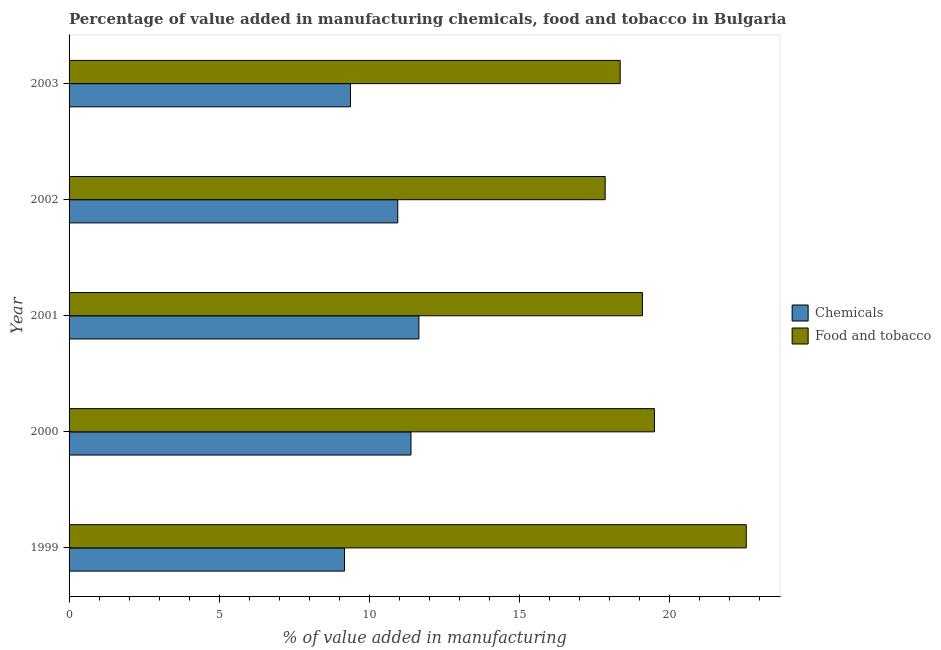Are the number of bars on each tick of the Y-axis equal?
Ensure brevity in your answer.  Yes. How many bars are there on the 3rd tick from the bottom?
Ensure brevity in your answer.  2. What is the value added by  manufacturing chemicals in 2000?
Provide a short and direct response. 11.4. Across all years, what is the maximum value added by  manufacturing chemicals?
Provide a succinct answer. 11.66. Across all years, what is the minimum value added by  manufacturing chemicals?
Your answer should be very brief. 9.18. In which year was the value added by  manufacturing chemicals maximum?
Ensure brevity in your answer.  2001. What is the total value added by manufacturing food and tobacco in the graph?
Provide a short and direct response. 97.43. What is the difference between the value added by  manufacturing chemicals in 2001 and that in 2002?
Your answer should be very brief. 0.7. What is the difference between the value added by  manufacturing chemicals in 2001 and the value added by manufacturing food and tobacco in 2002?
Your answer should be compact. -6.21. What is the average value added by  manufacturing chemicals per year?
Provide a short and direct response. 10.51. In the year 1999, what is the difference between the value added by  manufacturing chemicals and value added by manufacturing food and tobacco?
Provide a short and direct response. -13.39. What is the ratio of the value added by manufacturing food and tobacco in 1999 to that in 2003?
Offer a very short reply. 1.23. Is the value added by  manufacturing chemicals in 1999 less than that in 2003?
Offer a terse response. Yes. What is the difference between the highest and the second highest value added by  manufacturing chemicals?
Offer a terse response. 0.26. In how many years, is the value added by manufacturing food and tobacco greater than the average value added by manufacturing food and tobacco taken over all years?
Make the answer very short. 2. Is the sum of the value added by  manufacturing chemicals in 2000 and 2001 greater than the maximum value added by manufacturing food and tobacco across all years?
Provide a short and direct response. Yes. What does the 2nd bar from the top in 2003 represents?
Ensure brevity in your answer.  Chemicals. What does the 1st bar from the bottom in 1999 represents?
Your response must be concise. Chemicals. How many bars are there?
Your response must be concise. 10. What is the difference between two consecutive major ticks on the X-axis?
Offer a very short reply. 5. Are the values on the major ticks of X-axis written in scientific E-notation?
Provide a short and direct response. No. Does the graph contain grids?
Ensure brevity in your answer.  No. What is the title of the graph?
Ensure brevity in your answer.  Percentage of value added in manufacturing chemicals, food and tobacco in Bulgaria. What is the label or title of the X-axis?
Provide a short and direct response. % of value added in manufacturing. What is the label or title of the Y-axis?
Offer a terse response. Year. What is the % of value added in manufacturing of Chemicals in 1999?
Offer a very short reply. 9.18. What is the % of value added in manufacturing of Food and tobacco in 1999?
Keep it short and to the point. 22.57. What is the % of value added in manufacturing of Chemicals in 2000?
Provide a short and direct response. 11.4. What is the % of value added in manufacturing in Food and tobacco in 2000?
Provide a short and direct response. 19.51. What is the % of value added in manufacturing of Chemicals in 2001?
Your answer should be very brief. 11.66. What is the % of value added in manufacturing in Food and tobacco in 2001?
Make the answer very short. 19.11. What is the % of value added in manufacturing in Chemicals in 2002?
Your answer should be compact. 10.95. What is the % of value added in manufacturing of Food and tobacco in 2002?
Your answer should be very brief. 17.87. What is the % of value added in manufacturing of Chemicals in 2003?
Give a very brief answer. 9.38. What is the % of value added in manufacturing of Food and tobacco in 2003?
Provide a succinct answer. 18.37. Across all years, what is the maximum % of value added in manufacturing in Chemicals?
Ensure brevity in your answer.  11.66. Across all years, what is the maximum % of value added in manufacturing in Food and tobacco?
Provide a succinct answer. 22.57. Across all years, what is the minimum % of value added in manufacturing in Chemicals?
Give a very brief answer. 9.18. Across all years, what is the minimum % of value added in manufacturing in Food and tobacco?
Provide a short and direct response. 17.87. What is the total % of value added in manufacturing in Chemicals in the graph?
Your answer should be compact. 52.57. What is the total % of value added in manufacturing of Food and tobacco in the graph?
Your response must be concise. 97.43. What is the difference between the % of value added in manufacturing in Chemicals in 1999 and that in 2000?
Provide a succinct answer. -2.22. What is the difference between the % of value added in manufacturing in Food and tobacco in 1999 and that in 2000?
Provide a succinct answer. 3.06. What is the difference between the % of value added in manufacturing in Chemicals in 1999 and that in 2001?
Offer a terse response. -2.48. What is the difference between the % of value added in manufacturing of Food and tobacco in 1999 and that in 2001?
Offer a terse response. 3.46. What is the difference between the % of value added in manufacturing in Chemicals in 1999 and that in 2002?
Provide a succinct answer. -1.77. What is the difference between the % of value added in manufacturing in Food and tobacco in 1999 and that in 2002?
Ensure brevity in your answer.  4.7. What is the difference between the % of value added in manufacturing in Chemicals in 1999 and that in 2003?
Your answer should be very brief. -0.2. What is the difference between the % of value added in manufacturing in Food and tobacco in 1999 and that in 2003?
Your answer should be very brief. 4.2. What is the difference between the % of value added in manufacturing in Chemicals in 2000 and that in 2001?
Offer a terse response. -0.26. What is the difference between the % of value added in manufacturing in Food and tobacco in 2000 and that in 2001?
Offer a very short reply. 0.4. What is the difference between the % of value added in manufacturing of Chemicals in 2000 and that in 2002?
Keep it short and to the point. 0.44. What is the difference between the % of value added in manufacturing in Food and tobacco in 2000 and that in 2002?
Ensure brevity in your answer.  1.64. What is the difference between the % of value added in manufacturing of Chemicals in 2000 and that in 2003?
Give a very brief answer. 2.02. What is the difference between the % of value added in manufacturing in Food and tobacco in 2000 and that in 2003?
Give a very brief answer. 1.14. What is the difference between the % of value added in manufacturing in Chemicals in 2001 and that in 2002?
Your answer should be compact. 0.7. What is the difference between the % of value added in manufacturing of Food and tobacco in 2001 and that in 2002?
Your response must be concise. 1.24. What is the difference between the % of value added in manufacturing in Chemicals in 2001 and that in 2003?
Keep it short and to the point. 2.28. What is the difference between the % of value added in manufacturing of Food and tobacco in 2001 and that in 2003?
Make the answer very short. 0.74. What is the difference between the % of value added in manufacturing of Chemicals in 2002 and that in 2003?
Give a very brief answer. 1.58. What is the difference between the % of value added in manufacturing of Food and tobacco in 2002 and that in 2003?
Your answer should be compact. -0.5. What is the difference between the % of value added in manufacturing in Chemicals in 1999 and the % of value added in manufacturing in Food and tobacco in 2000?
Offer a terse response. -10.33. What is the difference between the % of value added in manufacturing of Chemicals in 1999 and the % of value added in manufacturing of Food and tobacco in 2001?
Offer a terse response. -9.93. What is the difference between the % of value added in manufacturing in Chemicals in 1999 and the % of value added in manufacturing in Food and tobacco in 2002?
Give a very brief answer. -8.69. What is the difference between the % of value added in manufacturing of Chemicals in 1999 and the % of value added in manufacturing of Food and tobacco in 2003?
Make the answer very short. -9.19. What is the difference between the % of value added in manufacturing of Chemicals in 2000 and the % of value added in manufacturing of Food and tobacco in 2001?
Offer a terse response. -7.71. What is the difference between the % of value added in manufacturing of Chemicals in 2000 and the % of value added in manufacturing of Food and tobacco in 2002?
Make the answer very short. -6.47. What is the difference between the % of value added in manufacturing of Chemicals in 2000 and the % of value added in manufacturing of Food and tobacco in 2003?
Your answer should be very brief. -6.97. What is the difference between the % of value added in manufacturing of Chemicals in 2001 and the % of value added in manufacturing of Food and tobacco in 2002?
Offer a terse response. -6.21. What is the difference between the % of value added in manufacturing of Chemicals in 2001 and the % of value added in manufacturing of Food and tobacco in 2003?
Your response must be concise. -6.71. What is the difference between the % of value added in manufacturing in Chemicals in 2002 and the % of value added in manufacturing in Food and tobacco in 2003?
Make the answer very short. -7.41. What is the average % of value added in manufacturing of Chemicals per year?
Provide a succinct answer. 10.51. What is the average % of value added in manufacturing of Food and tobacco per year?
Your answer should be very brief. 19.49. In the year 1999, what is the difference between the % of value added in manufacturing of Chemicals and % of value added in manufacturing of Food and tobacco?
Your answer should be compact. -13.39. In the year 2000, what is the difference between the % of value added in manufacturing in Chemicals and % of value added in manufacturing in Food and tobacco?
Your response must be concise. -8.12. In the year 2001, what is the difference between the % of value added in manufacturing of Chemicals and % of value added in manufacturing of Food and tobacco?
Offer a terse response. -7.45. In the year 2002, what is the difference between the % of value added in manufacturing in Chemicals and % of value added in manufacturing in Food and tobacco?
Offer a very short reply. -6.91. In the year 2003, what is the difference between the % of value added in manufacturing in Chemicals and % of value added in manufacturing in Food and tobacco?
Provide a succinct answer. -8.99. What is the ratio of the % of value added in manufacturing of Chemicals in 1999 to that in 2000?
Your response must be concise. 0.81. What is the ratio of the % of value added in manufacturing in Food and tobacco in 1999 to that in 2000?
Provide a succinct answer. 1.16. What is the ratio of the % of value added in manufacturing of Chemicals in 1999 to that in 2001?
Keep it short and to the point. 0.79. What is the ratio of the % of value added in manufacturing in Food and tobacco in 1999 to that in 2001?
Your response must be concise. 1.18. What is the ratio of the % of value added in manufacturing in Chemicals in 1999 to that in 2002?
Your answer should be compact. 0.84. What is the ratio of the % of value added in manufacturing in Food and tobacco in 1999 to that in 2002?
Keep it short and to the point. 1.26. What is the ratio of the % of value added in manufacturing of Chemicals in 1999 to that in 2003?
Your answer should be compact. 0.98. What is the ratio of the % of value added in manufacturing of Food and tobacco in 1999 to that in 2003?
Make the answer very short. 1.23. What is the ratio of the % of value added in manufacturing in Chemicals in 2000 to that in 2001?
Your response must be concise. 0.98. What is the ratio of the % of value added in manufacturing of Chemicals in 2000 to that in 2002?
Offer a very short reply. 1.04. What is the ratio of the % of value added in manufacturing of Food and tobacco in 2000 to that in 2002?
Give a very brief answer. 1.09. What is the ratio of the % of value added in manufacturing in Chemicals in 2000 to that in 2003?
Keep it short and to the point. 1.21. What is the ratio of the % of value added in manufacturing in Food and tobacco in 2000 to that in 2003?
Your answer should be compact. 1.06. What is the ratio of the % of value added in manufacturing in Chemicals in 2001 to that in 2002?
Offer a terse response. 1.06. What is the ratio of the % of value added in manufacturing of Food and tobacco in 2001 to that in 2002?
Offer a terse response. 1.07. What is the ratio of the % of value added in manufacturing in Chemicals in 2001 to that in 2003?
Provide a short and direct response. 1.24. What is the ratio of the % of value added in manufacturing in Food and tobacco in 2001 to that in 2003?
Ensure brevity in your answer.  1.04. What is the ratio of the % of value added in manufacturing of Chemicals in 2002 to that in 2003?
Provide a succinct answer. 1.17. What is the ratio of the % of value added in manufacturing of Food and tobacco in 2002 to that in 2003?
Give a very brief answer. 0.97. What is the difference between the highest and the second highest % of value added in manufacturing of Chemicals?
Make the answer very short. 0.26. What is the difference between the highest and the second highest % of value added in manufacturing of Food and tobacco?
Keep it short and to the point. 3.06. What is the difference between the highest and the lowest % of value added in manufacturing in Chemicals?
Provide a short and direct response. 2.48. What is the difference between the highest and the lowest % of value added in manufacturing in Food and tobacco?
Your answer should be compact. 4.7. 